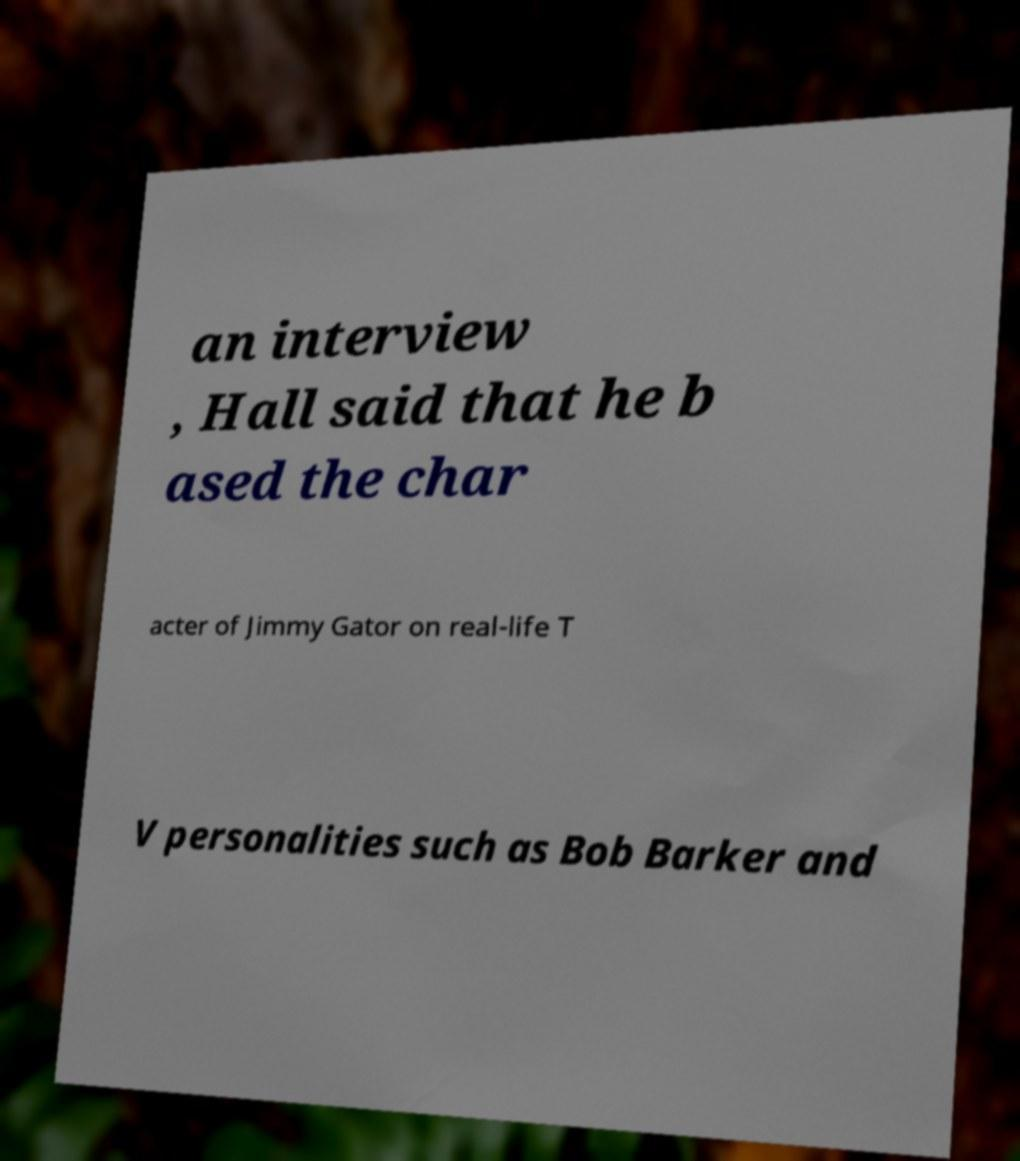Can you accurately transcribe the text from the provided image for me? an interview , Hall said that he b ased the char acter of Jimmy Gator on real-life T V personalities such as Bob Barker and 